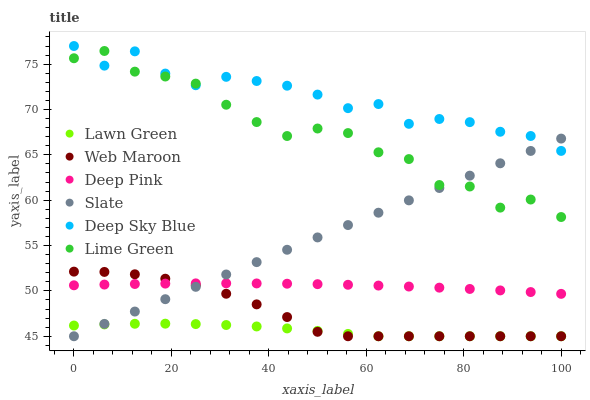Does Lawn Green have the minimum area under the curve?
Answer yes or no. Yes. Does Deep Sky Blue have the maximum area under the curve?
Answer yes or no. Yes. Does Deep Pink have the minimum area under the curve?
Answer yes or no. No. Does Deep Pink have the maximum area under the curve?
Answer yes or no. No. Is Slate the smoothest?
Answer yes or no. Yes. Is Lime Green the roughest?
Answer yes or no. Yes. Is Deep Pink the smoothest?
Answer yes or no. No. Is Deep Pink the roughest?
Answer yes or no. No. Does Lawn Green have the lowest value?
Answer yes or no. Yes. Does Deep Pink have the lowest value?
Answer yes or no. No. Does Deep Sky Blue have the highest value?
Answer yes or no. Yes. Does Deep Pink have the highest value?
Answer yes or no. No. Is Deep Pink less than Deep Sky Blue?
Answer yes or no. Yes. Is Deep Sky Blue greater than Web Maroon?
Answer yes or no. Yes. Does Lawn Green intersect Slate?
Answer yes or no. Yes. Is Lawn Green less than Slate?
Answer yes or no. No. Is Lawn Green greater than Slate?
Answer yes or no. No. Does Deep Pink intersect Deep Sky Blue?
Answer yes or no. No. 